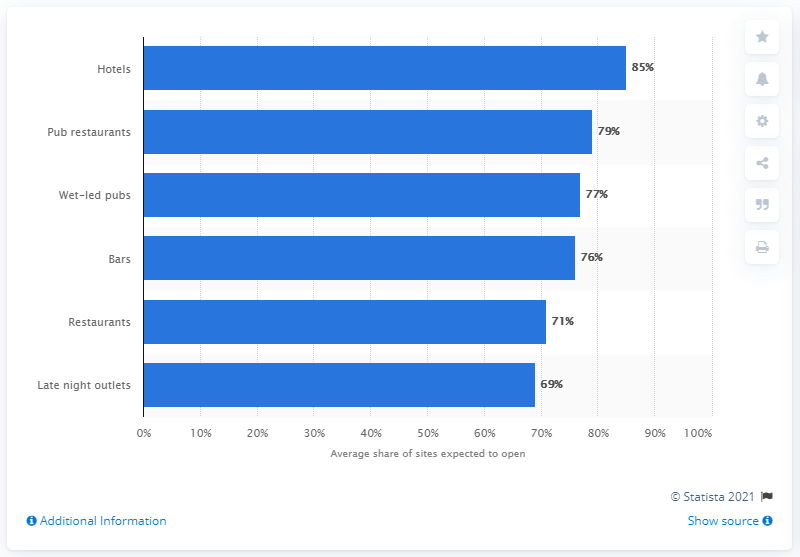Mention a couple of crucial points in this snapshot. According to a recent survey, more than 85% of hotels in the UK are expected to re-open after the coronavirus measures are lifted. 